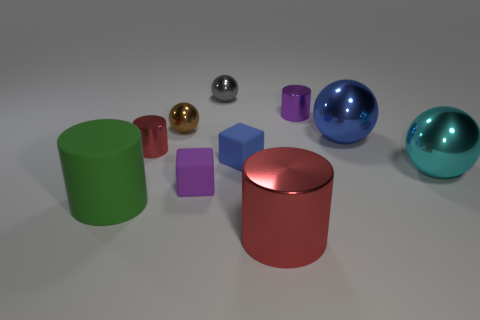There is a blue object that is the same size as the green thing; what is its material?
Your answer should be very brief. Metal. Do the large red shiny thing and the tiny red object have the same shape?
Your response must be concise. Yes. Is the material of the red object behind the large matte cylinder the same as the red thing on the right side of the small brown thing?
Offer a very short reply. Yes. What number of things are shiny objects that are left of the tiny gray metal sphere or red things in front of the big matte thing?
Provide a short and direct response. 3. Are there any other things that have the same shape as the blue matte thing?
Your answer should be very brief. Yes. What number of big brown metallic cylinders are there?
Ensure brevity in your answer.  0. Are there any blue shiny balls that have the same size as the purple cube?
Give a very brief answer. No. Is the material of the big blue thing the same as the blue thing on the left side of the big blue shiny thing?
Your answer should be compact. No. What is the purple object right of the blue matte block made of?
Your answer should be very brief. Metal. The blue block is what size?
Keep it short and to the point. Small. 